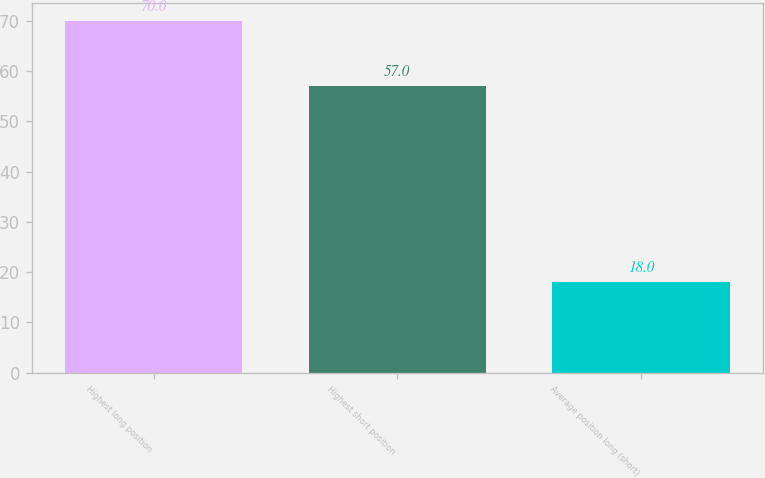Convert chart to OTSL. <chart><loc_0><loc_0><loc_500><loc_500><bar_chart><fcel>Highest long position<fcel>Highest short position<fcel>Average position long (short)<nl><fcel>70<fcel>57<fcel>18<nl></chart> 